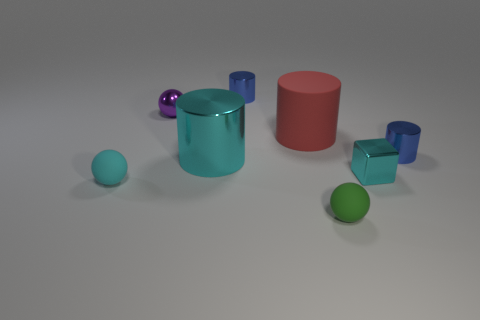Does the green thing have the same shape as the tiny blue shiny thing that is on the right side of the small metallic block?
Provide a succinct answer. No. There is a small shiny sphere behind the large red thing; what is its color?
Ensure brevity in your answer.  Purple. There is a blue cylinder that is in front of the small blue metal cylinder to the left of the green matte ball; what size is it?
Ensure brevity in your answer.  Small. There is a blue shiny object that is on the right side of the shiny block; is its shape the same as the big cyan object?
Your response must be concise. Yes. What material is the cyan object that is the same shape as the red object?
Offer a very short reply. Metal. What number of objects are small cylinders in front of the small purple shiny thing or cyan metal objects that are to the left of the small cyan metallic thing?
Your answer should be compact. 2. Is the color of the tiny metallic block the same as the rubber ball on the right side of the large metallic thing?
Give a very brief answer. No. What shape is the tiny cyan object that is the same material as the green sphere?
Give a very brief answer. Sphere. How many blue shiny cylinders are there?
Your response must be concise. 2. How many objects are either rubber things in front of the small cyan matte thing or large matte cylinders?
Your response must be concise. 2. 